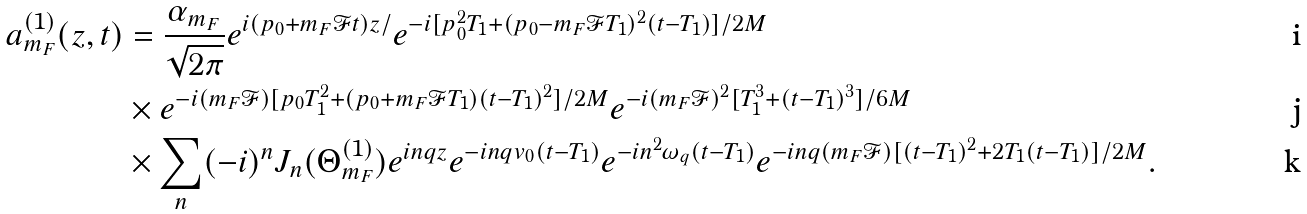<formula> <loc_0><loc_0><loc_500><loc_500>a _ { m _ { F } } ^ { ( 1 ) } ( z , t ) & = \frac { \alpha _ { m _ { F } } } { \sqrt { 2 \pi } } e ^ { i ( p _ { 0 } + m _ { F } \mathcal { F } t ) z / } e ^ { - i [ p _ { 0 } ^ { 2 } T _ { 1 } + ( p _ { 0 } - m _ { F } \mathcal { F } T _ { 1 } ) ^ { 2 } ( t - T _ { 1 } ) ] / 2 M } \\ & \times e ^ { - i ( m _ { F } \mathcal { F } ) [ p _ { 0 } T _ { 1 } ^ { 2 } + ( p _ { 0 } + m _ { F } \mathcal { F } T _ { 1 } ) ( t - T _ { 1 } ) ^ { 2 } ] / 2 M } e ^ { - i ( m _ { F } \mathcal { F } ) ^ { 2 } [ T _ { 1 } ^ { 3 } + ( t - T _ { 1 } ) ^ { 3 } ] / 6 M } \\ & \times \sum _ { n } ( - i ) ^ { n } J _ { n } ( \Theta _ { m _ { F } } ^ { ( 1 ) } ) e ^ { i n q z } e ^ { - i n q v _ { 0 } ( t - T _ { 1 } ) } e ^ { - i n ^ { 2 } \omega _ { q } ( t - T _ { 1 } ) } e ^ { - i n q ( m _ { F } \mathcal { F } ) [ ( t - T _ { 1 } ) ^ { 2 } + 2 T _ { 1 } ( t - T _ { 1 } ) ] / 2 M } .</formula> 